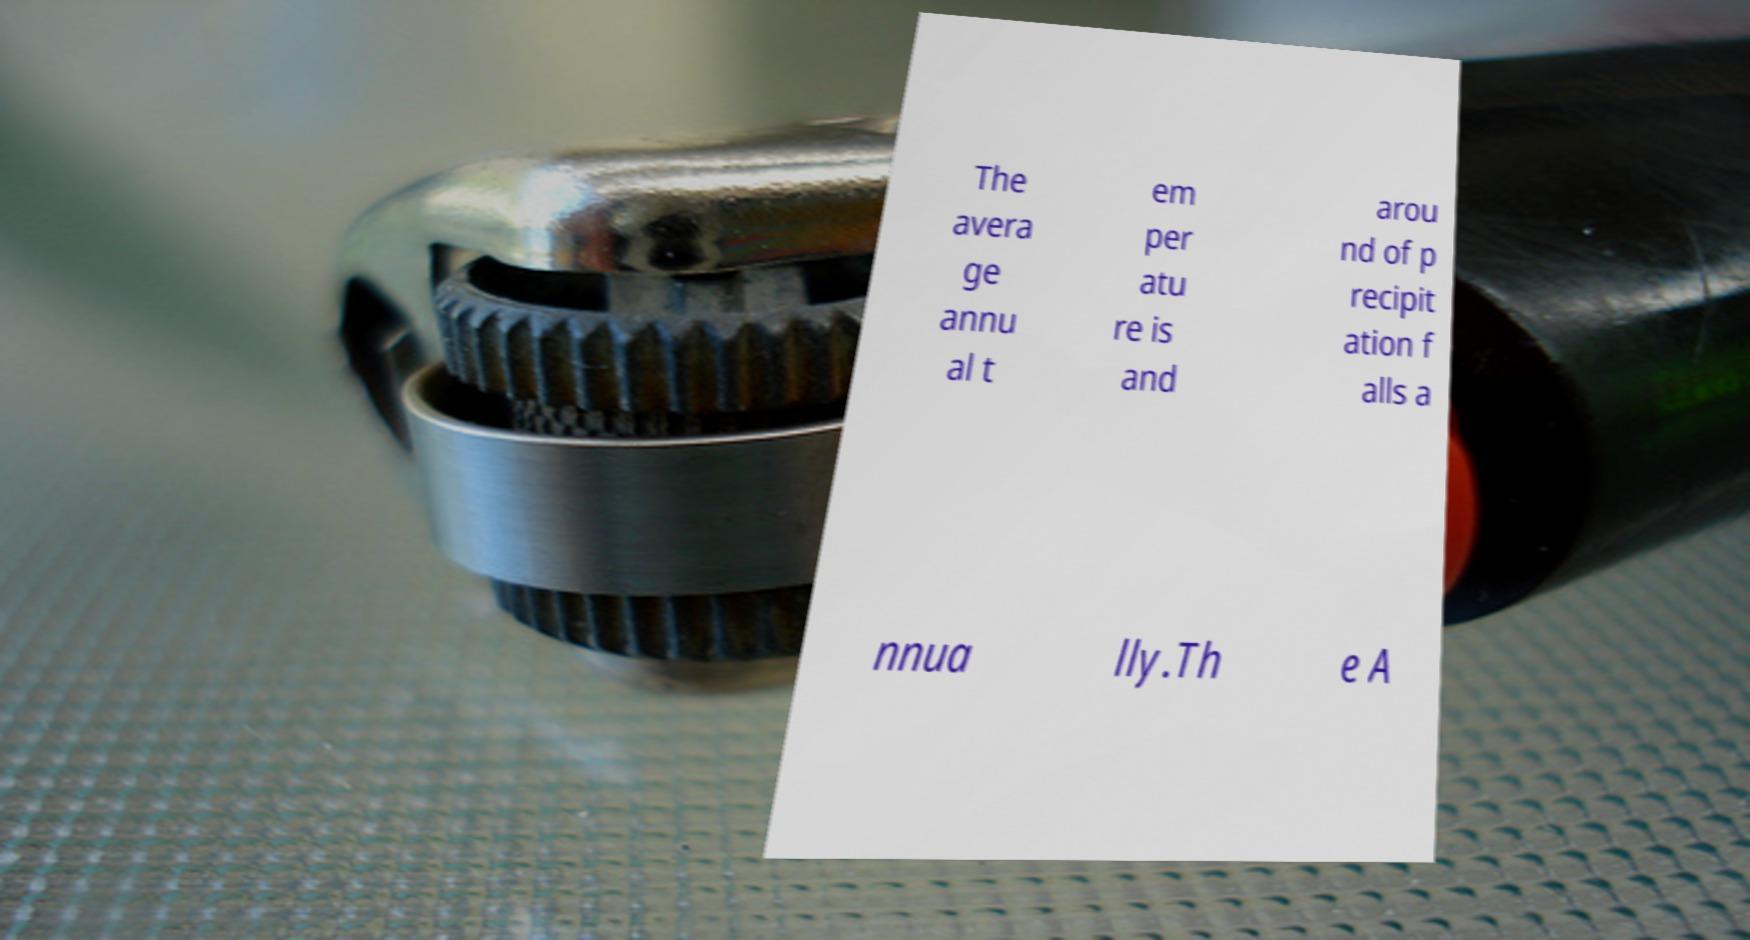There's text embedded in this image that I need extracted. Can you transcribe it verbatim? The avera ge annu al t em per atu re is and arou nd of p recipit ation f alls a nnua lly.Th e A 